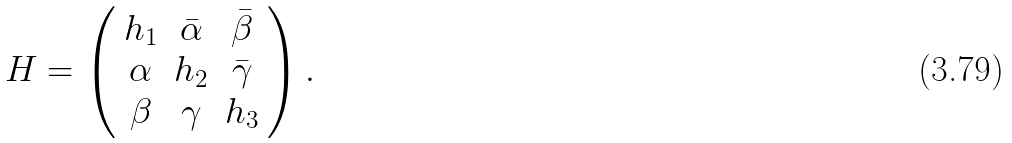<formula> <loc_0><loc_0><loc_500><loc_500>H = \left ( \begin{array} { c c c } h _ { 1 } & \bar { \alpha } & \bar { \beta } \\ \alpha & h _ { 2 } & \bar { \gamma } \\ \beta & \gamma & h _ { 3 } \end{array} \right ) .</formula> 